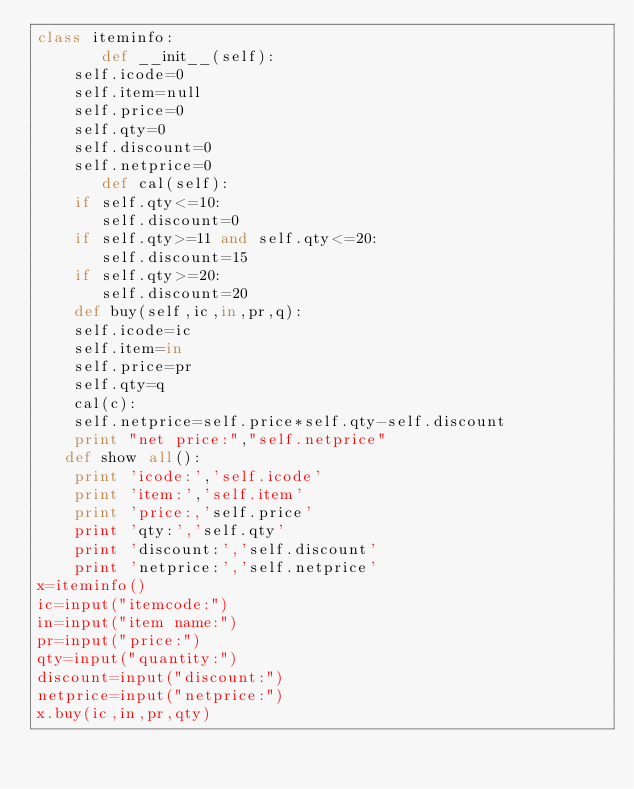Convert code to text. <code><loc_0><loc_0><loc_500><loc_500><_Python_>class iteminfo:
       def __init__(self):
	self.icode=0
	self.item=null
	self.price=0
	self.qty=0
	self.discount=0
	self.netprice=0
       def cal(self):
	if self.qty<=10:
	   self.discount=0
	if self.qty>=11 and self.qty<=20:
	   self.discount=15
	if self.qty>=20:
	   self.discount=20
    def buy(self,ic,in,pr,q):
	self.icode=ic
	self.item=in
	self.price=pr
	self.qty=q
	cal(c):
	self.netprice=self.price*self.qty-self.discount
	print "net price:","self.netprice"
   def show all():
	print 'icode:','self.icode'
	print 'item:','self.item'
	print 'price:,'self.price'
	print 'qty:','self.qty'
	print 'discount:','self.discount'
	print 'netprice:','self.netprice'
x=iteminfo()
ic=input("itemcode:")
in=input("item name:")
pr=input("price:")
qty=input("quantity:")
discount=input("discount:")
netprice=input("netprice:")
x.buy(ic,in,pr,qty)

			</code> 